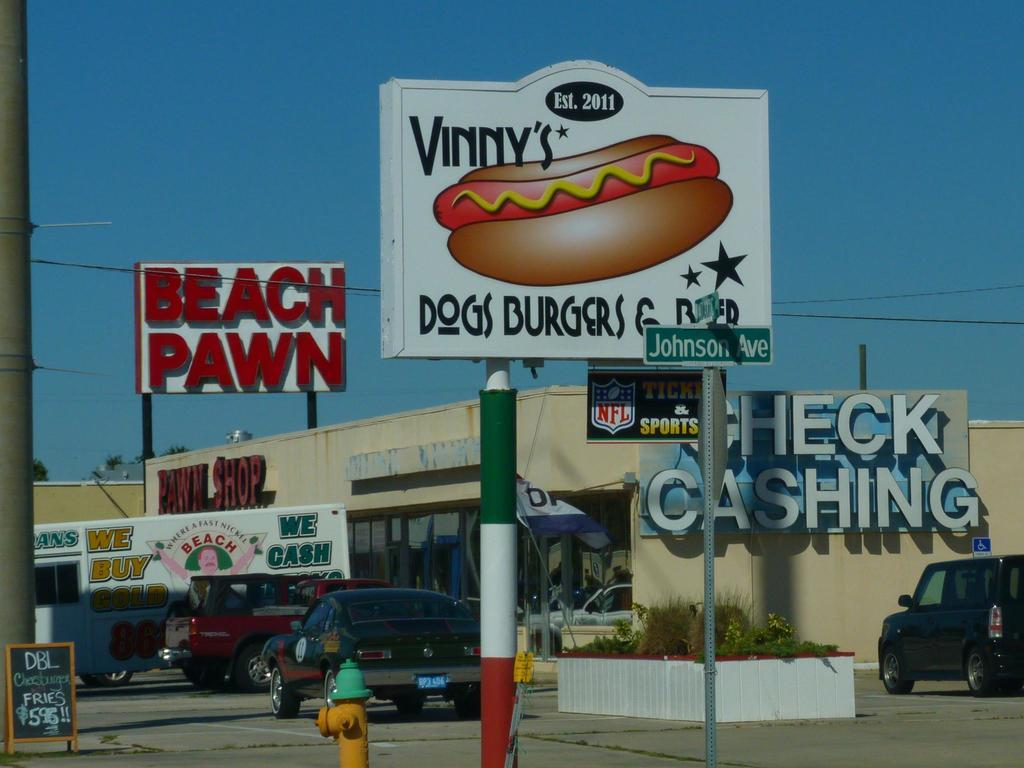<image>
Relay a brief, clear account of the picture shown. a burger place that is next to a pawn shop 